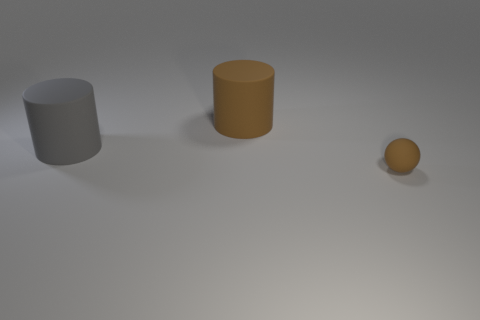What is the size of the cylinder that is the same color as the tiny matte sphere?
Provide a short and direct response. Large. What size is the brown sphere that is the same material as the gray cylinder?
Provide a short and direct response. Small. What is the shape of the other rubber object that is the same color as the tiny object?
Provide a succinct answer. Cylinder. There is a gray thing that is the same material as the sphere; what shape is it?
Give a very brief answer. Cylinder. What number of other objects are there of the same size as the matte sphere?
Offer a terse response. 0. Do the ball and the brown matte object that is behind the tiny ball have the same size?
Your answer should be very brief. No. There is a brown rubber object that is right of the brown thing behind the tiny thing on the right side of the large brown cylinder; what shape is it?
Ensure brevity in your answer.  Sphere. Are there fewer big green shiny cylinders than large objects?
Give a very brief answer. Yes. There is a big brown matte cylinder; are there any large rubber things behind it?
Ensure brevity in your answer.  No. There is a matte object that is both left of the small thing and in front of the big brown rubber object; what is its shape?
Your answer should be very brief. Cylinder. 